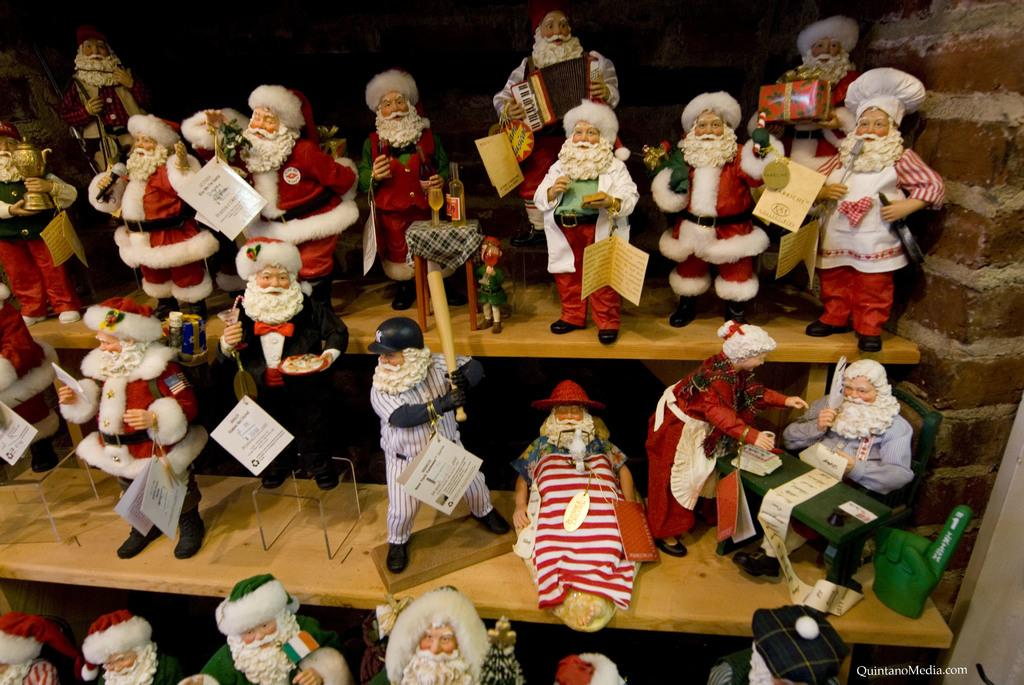What objects can be seen in the image? There are toys in the image. Where are the toys located? The toys are on a wall shelf. What type of steel is used to make the writing on the toys in the image? There is no writing on the toys in the image, and therefore no steel is involved. 